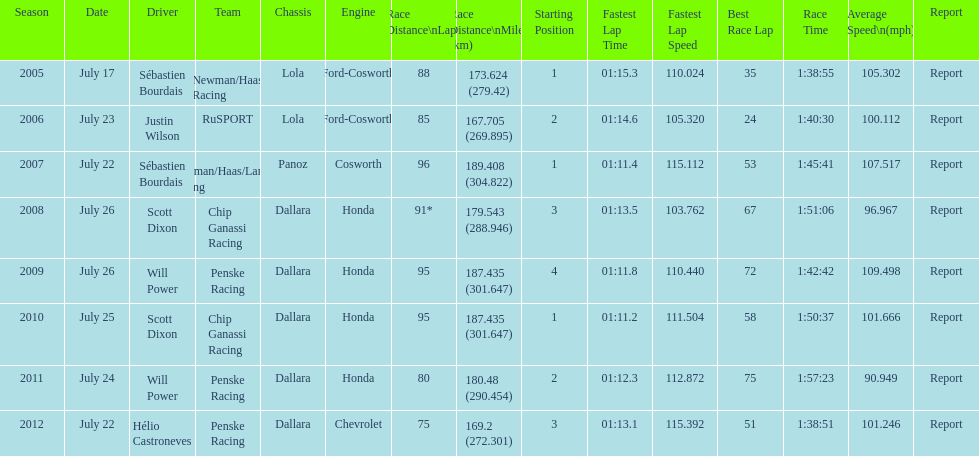Was the average speed in the year 2011 of the indycar series above or below the average speed of the year before? Below. 